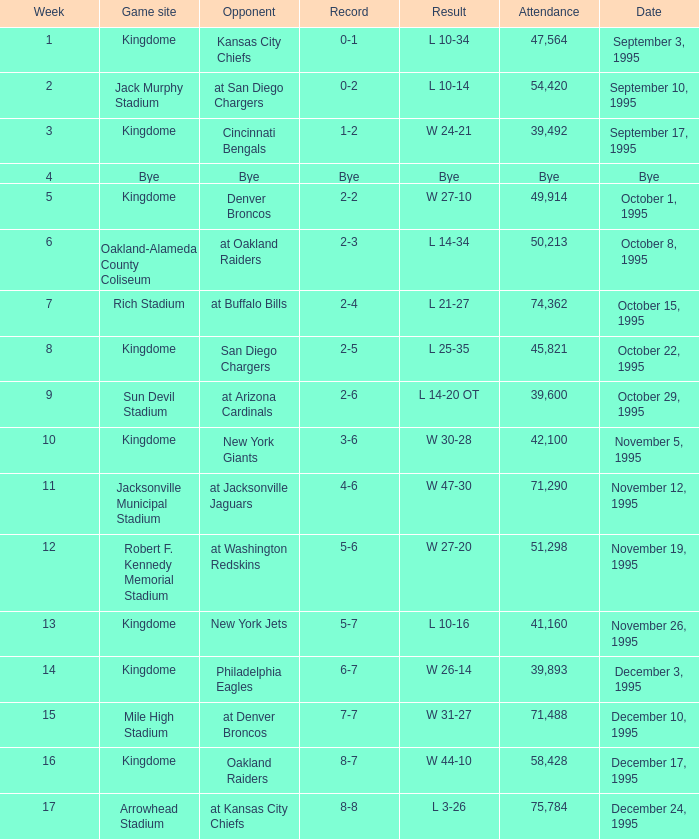Who was the opponent when the Seattle Seahawks had a record of 0-1? Kansas City Chiefs. 